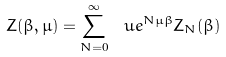Convert formula to latex. <formula><loc_0><loc_0><loc_500><loc_500>Z ( \beta , \mu ) = \sum _ { N = 0 } ^ { \infty } \ u e ^ { N \mu \beta } Z _ { N } ( \beta )</formula> 